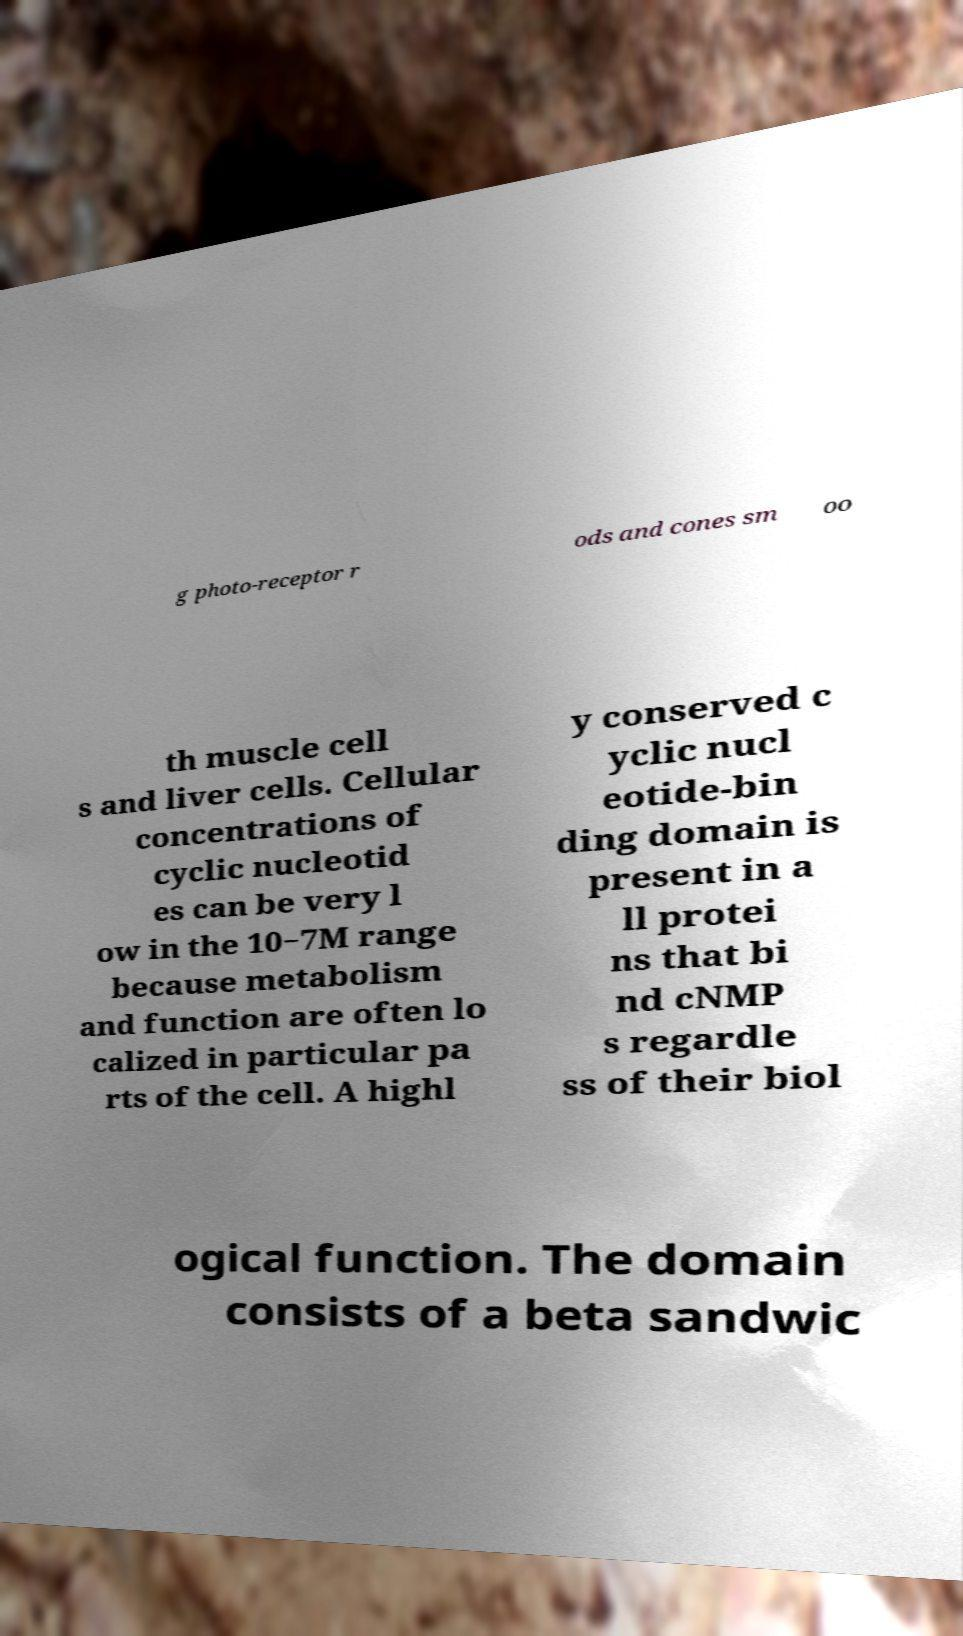Please read and relay the text visible in this image. What does it say? g photo-receptor r ods and cones sm oo th muscle cell s and liver cells. Cellular concentrations of cyclic nucleotid es can be very l ow in the 10−7M range because metabolism and function are often lo calized in particular pa rts of the cell. A highl y conserved c yclic nucl eotide-bin ding domain is present in a ll protei ns that bi nd cNMP s regardle ss of their biol ogical function. The domain consists of a beta sandwic 